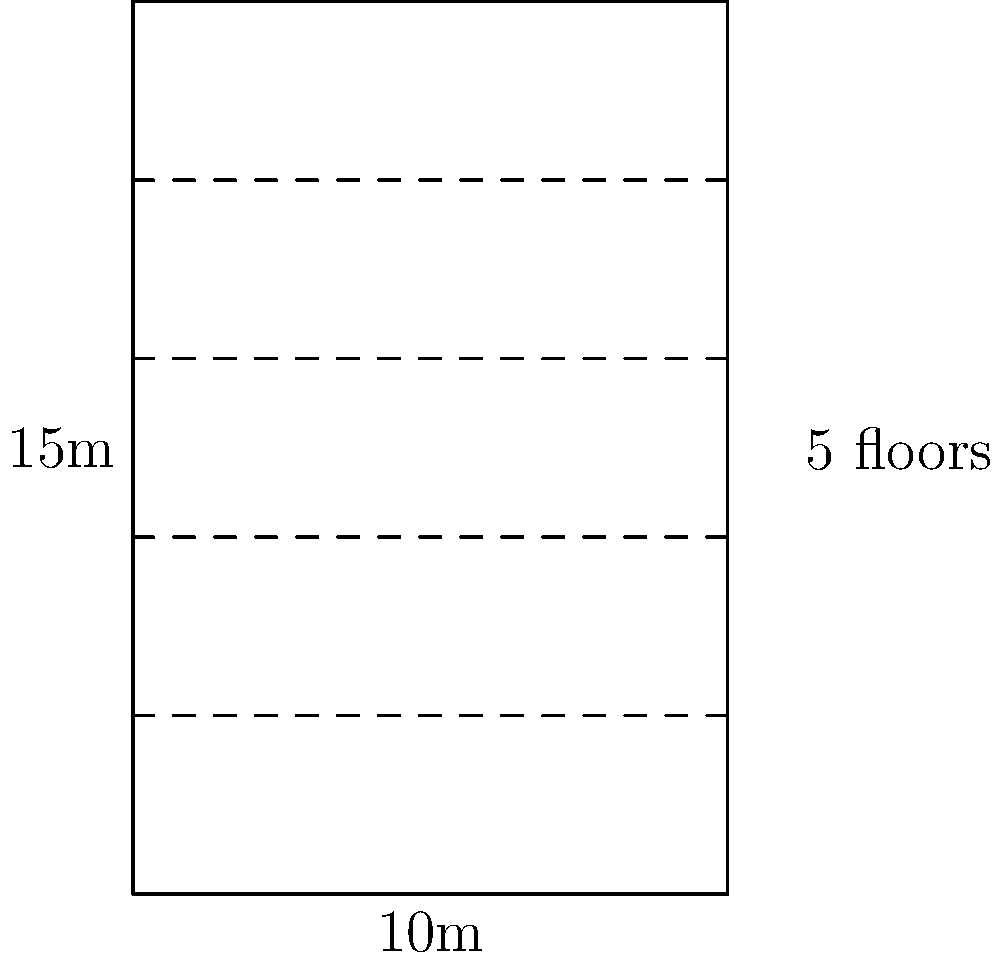A prestigious office building managed by JLL has a rectangular footprint measuring 10m by 15m and consists of 5 floors. Assuming each floor has the same dimensions, what is the total floor area of the building in square meters? To calculate the total floor area of the multi-story office building, we need to follow these steps:

1. Calculate the area of a single floor:
   Area of one floor = length $\times$ width
   $A = 10\text{ m} \times 15\text{ m} = 150\text{ m}^2$

2. Determine the number of floors:
   The building has 5 floors.

3. Calculate the total floor area:
   Total floor area = Area of one floor $\times$ Number of floors
   $A_{\text{total}} = 150\text{ m}^2 \times 5 = 750\text{ m}^2$

Therefore, the total floor area of the office building is 750 square meters.
Answer: $750\text{ m}^2$ 